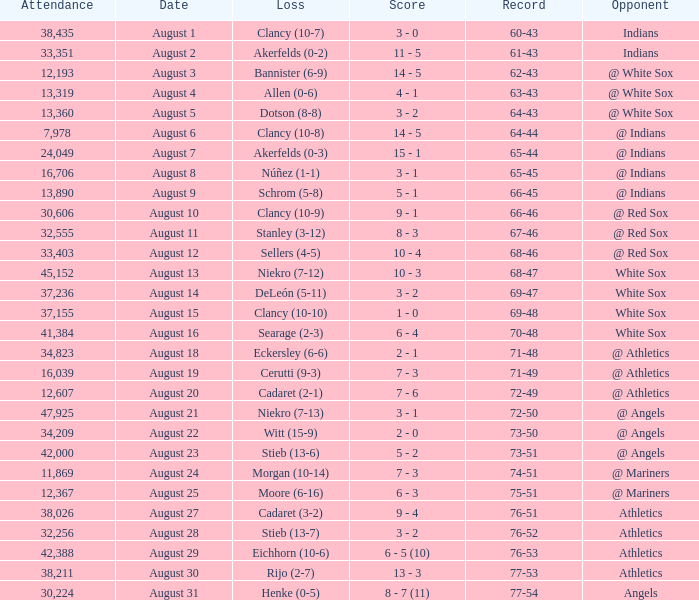What was the attendance when the record was 77-54? 30224.0. 